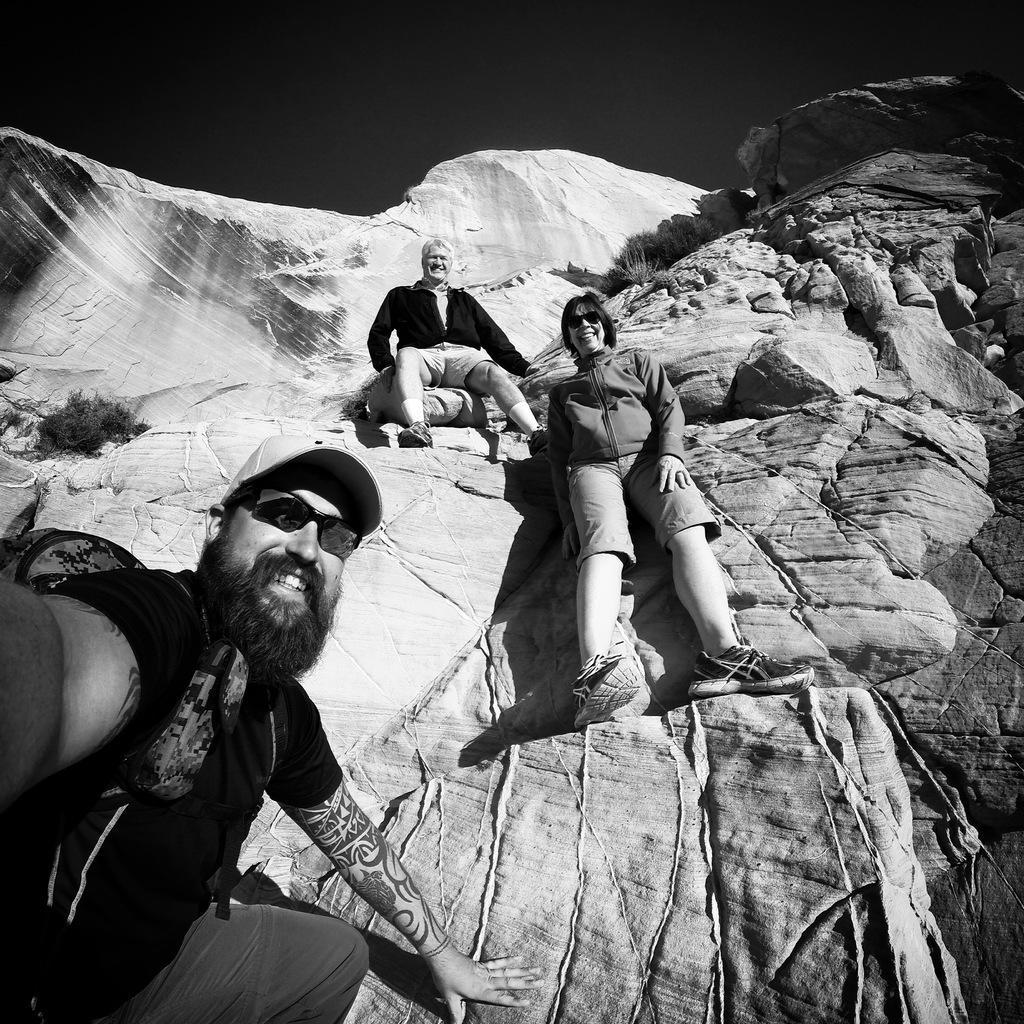Can you describe this image briefly? In this image there are three people sitting on the rocks. They are smiling. Behind them there are rocky mountains. At the top there is the sky. 